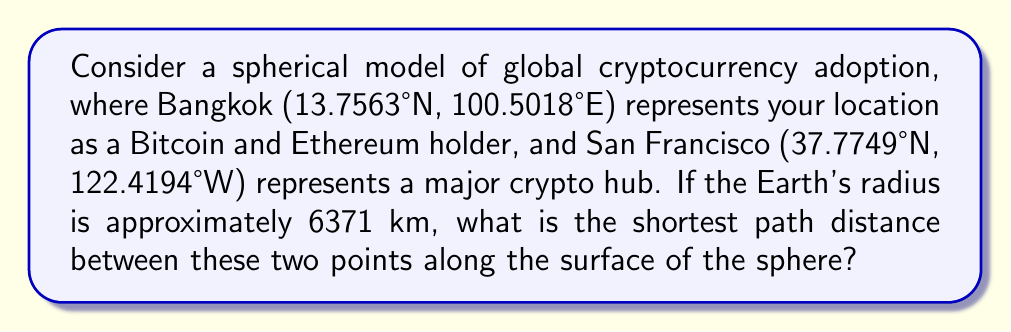Show me your answer to this math problem. To solve this problem, we'll use the great-circle distance formula, which gives the shortest path between two points on a sphere. The steps are as follows:

1. Convert the latitude and longitude coordinates to radians:
   Bangkok: $\phi_1 = 13.7563° \times \frac{\pi}{180} = 0.2401$ rad, $\lambda_1 = 100.5018° \times \frac{\pi}{180} = 1.7542$ rad
   San Francisco: $\phi_2 = 37.7749° \times \frac{\pi}{180} = 0.6593$ rad, $\lambda_2 = -122.4194° \times \frac{\pi}{180} = -2.1368$ rad

2. Calculate the central angle $\Delta\sigma$ using the Haversine formula:
   $$\Delta\sigma = 2 \arcsin\left(\sqrt{\sin^2\left(\frac{\phi_2 - \phi_1}{2}\right) + \cos\phi_1 \cos\phi_2 \sin^2\left(\frac{\lambda_2 - \lambda_1}{2}\right)}\right)$$

3. Substitute the values:
   $$\Delta\sigma = 2 \arcsin\left(\sqrt{\sin^2\left(\frac{0.6593 - 0.2401}{2}\right) + \cos(0.2401) \cos(0.6593) \sin^2\left(\frac{-2.1368 - 1.7542}{2}\right)}\right)$$

4. Calculate the result:
   $$\Delta\sigma \approx 2.0996$$

5. Multiply the central angle by the Earth's radius to get the distance:
   $$d = R \times \Delta\sigma = 6371 \times 2.0996 \approx 13376.36 \text{ km}$$

Therefore, the shortest path distance between Bangkok and San Francisco on this spherical model is approximately 13376.36 km.
Answer: 13376.36 km 